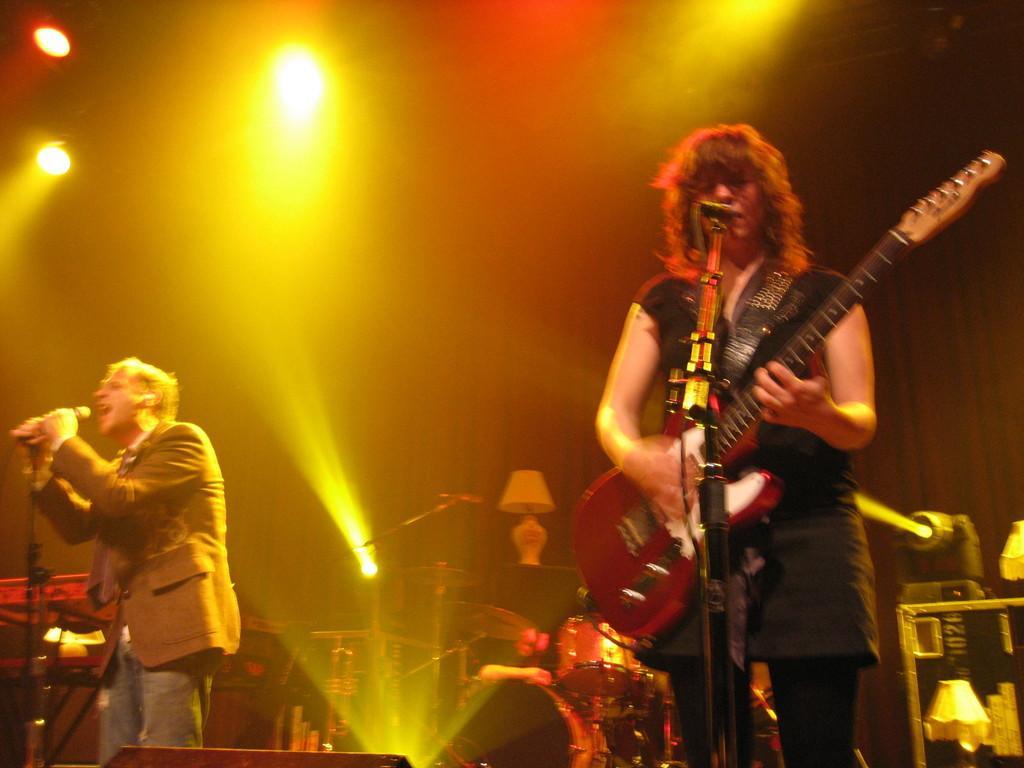In one or two sentences, can you explain what this image depicts? On the background we can see curtain lights and a lamp, drums. We can see one person standing in front of a mike and playing guitar. At the left side of the picture we can see a person holding a mike in his hand and singing. 